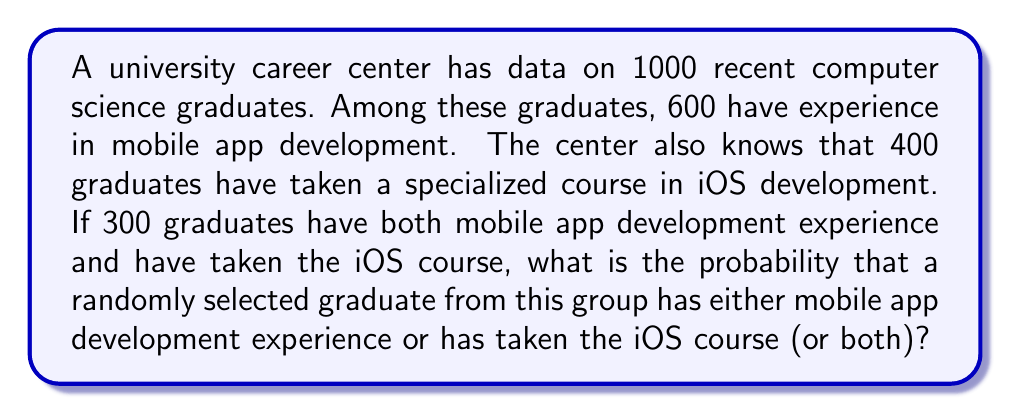Teach me how to tackle this problem. Let's approach this step-by-step using set theory and the addition rule of probability:

1) Let's define our events:
   A: Graduate has mobile app development experience
   B: Graduate has taken the iOS course

2) Given information:
   P(A) = 600/1000 = 0.6
   P(B) = 400/1000 = 0.4
   P(A ∩ B) = 300/1000 = 0.3

3) We want to find P(A ∪ B), which is the probability of A or B or both.

4) The addition rule of probability states:
   P(A ∪ B) = P(A) + P(B) - P(A ∩ B)

5) Substituting our values:
   P(A ∪ B) = 0.6 + 0.4 - 0.3

6) Calculating:
   P(A ∪ B) = 1 - 0.3 = 0.7

Therefore, the probability that a randomly selected graduate has either mobile app development experience or has taken the iOS course (or both) is 0.7 or 70%.
Answer: 0.7 